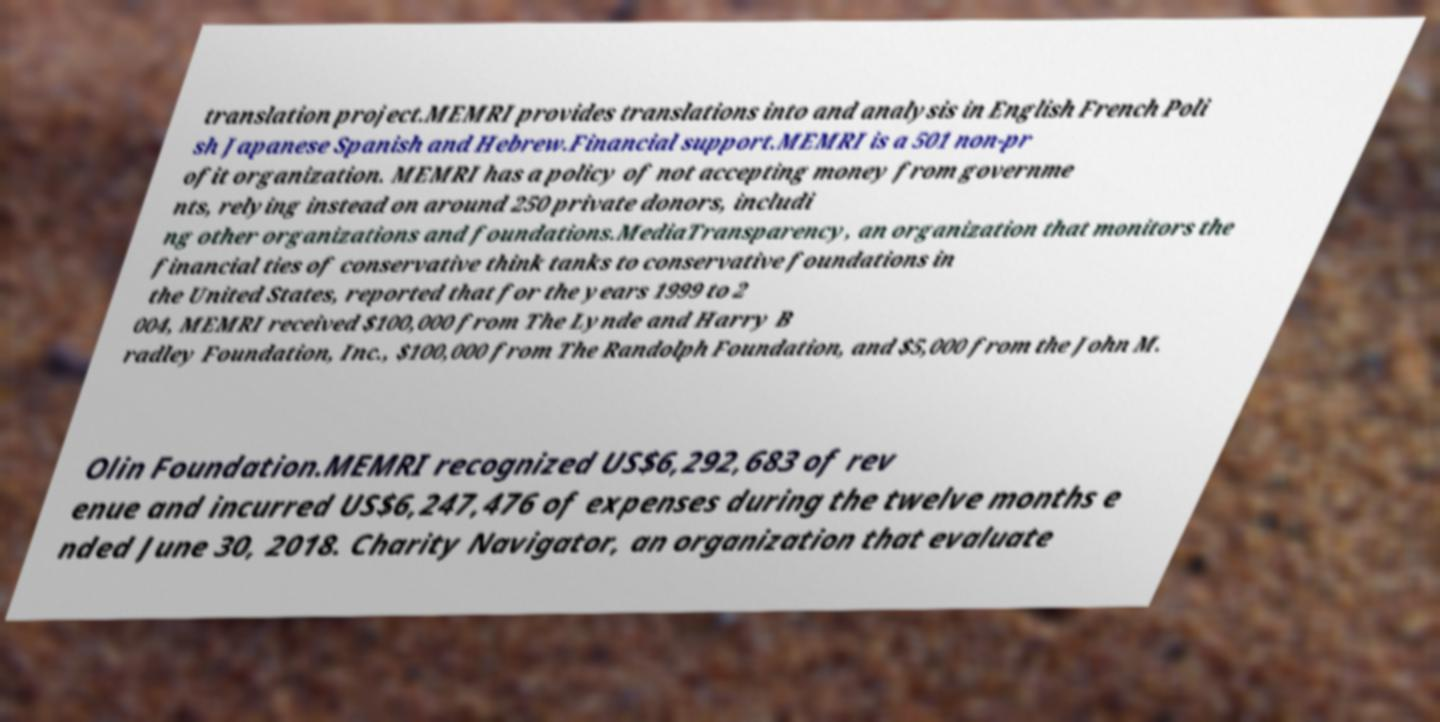What messages or text are displayed in this image? I need them in a readable, typed format. translation project.MEMRI provides translations into and analysis in English French Poli sh Japanese Spanish and Hebrew.Financial support.MEMRI is a 501 non-pr ofit organization. MEMRI has a policy of not accepting money from governme nts, relying instead on around 250 private donors, includi ng other organizations and foundations.MediaTransparency, an organization that monitors the financial ties of conservative think tanks to conservative foundations in the United States, reported that for the years 1999 to 2 004, MEMRI received $100,000 from The Lynde and Harry B radley Foundation, Inc., $100,000 from The Randolph Foundation, and $5,000 from the John M. Olin Foundation.MEMRI recognized US$6,292,683 of rev enue and incurred US$6,247,476 of expenses during the twelve months e nded June 30, 2018. Charity Navigator, an organization that evaluate 